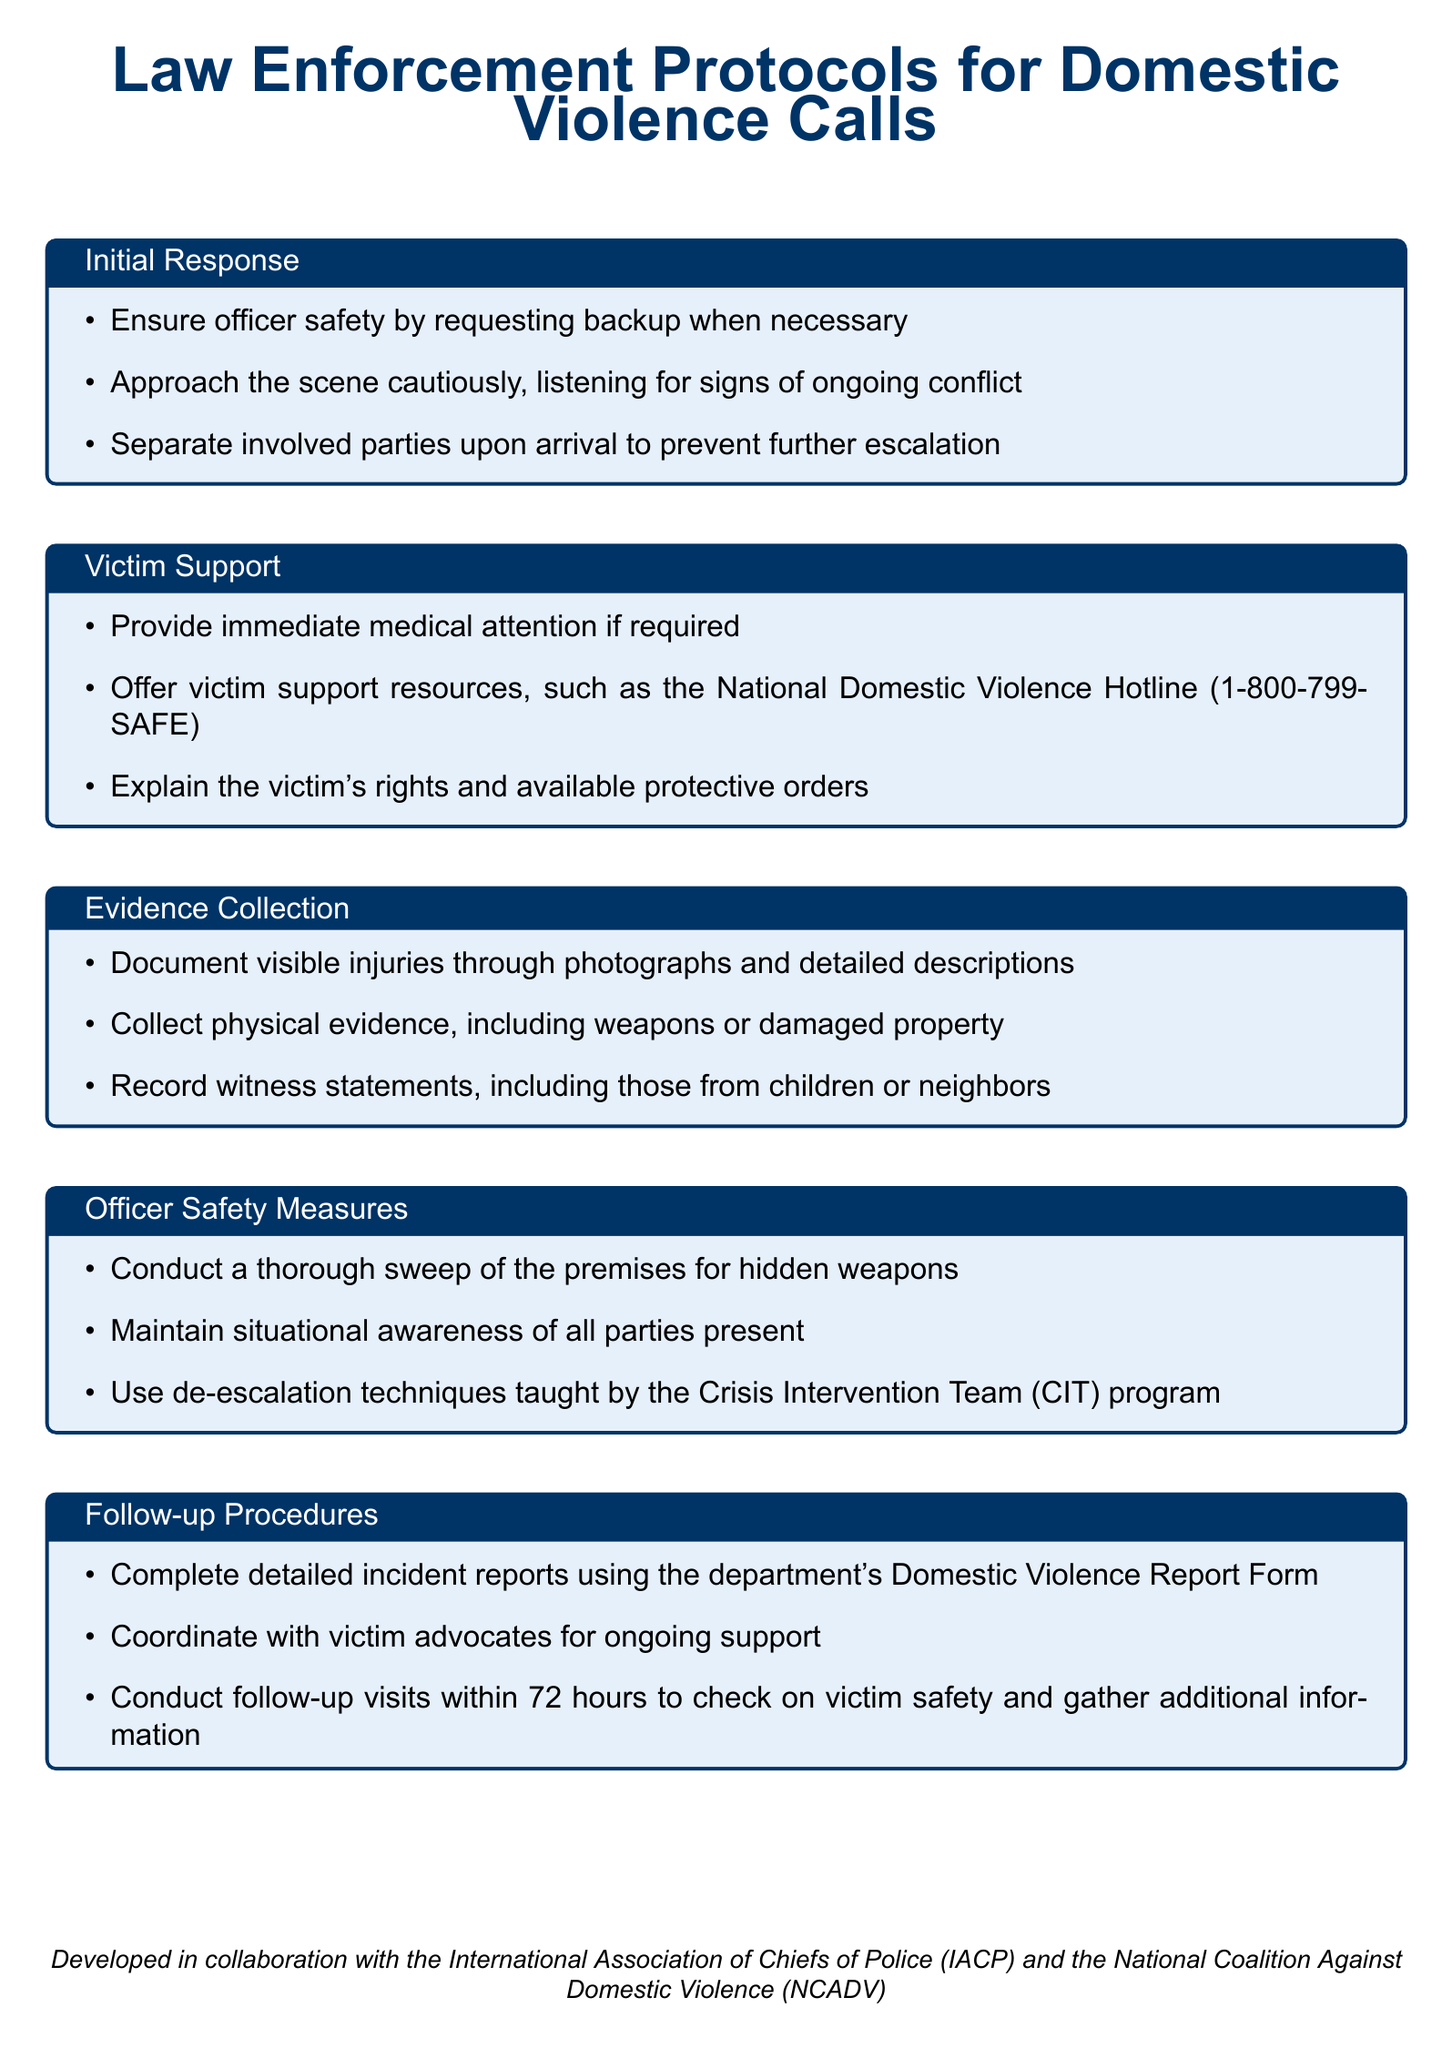what should an officer ensure for safety? The document states that officers should ensure safety by requesting backup when necessary.
Answer: backup what resources should be offered to victims? The document mentions offering victim support resources such as the National Domestic Violence Hotline.
Answer: National Domestic Violence Hotline (1-800-799-SAFE) what is a method for separating involved parties? The document suggests separating involved parties upon arrival to prevent further escalation.
Answer: separating involved parties how should visible injuries be documented? According to the document, visible injuries should be documented through photographs and detailed descriptions.
Answer: photographs and detailed descriptions what is a follow-up procedure to check on victim safety? The document indicates conducting follow-up visits within 72 hours to check on victim safety as a procedure.
Answer: within 72 hours what should be recorded from witnesses? The document states that witness statements, including those from children or neighbors, should be recorded.
Answer: witness statements what is a specific safety measure for officers during a call? The document highlights maintaining situational awareness of all parties present as a safety measure.
Answer: situational awareness what form should be used for incident reports? The document specifies using the department's Domestic Violence Report Form for incident reports.
Answer: Domestic Violence Report Form 